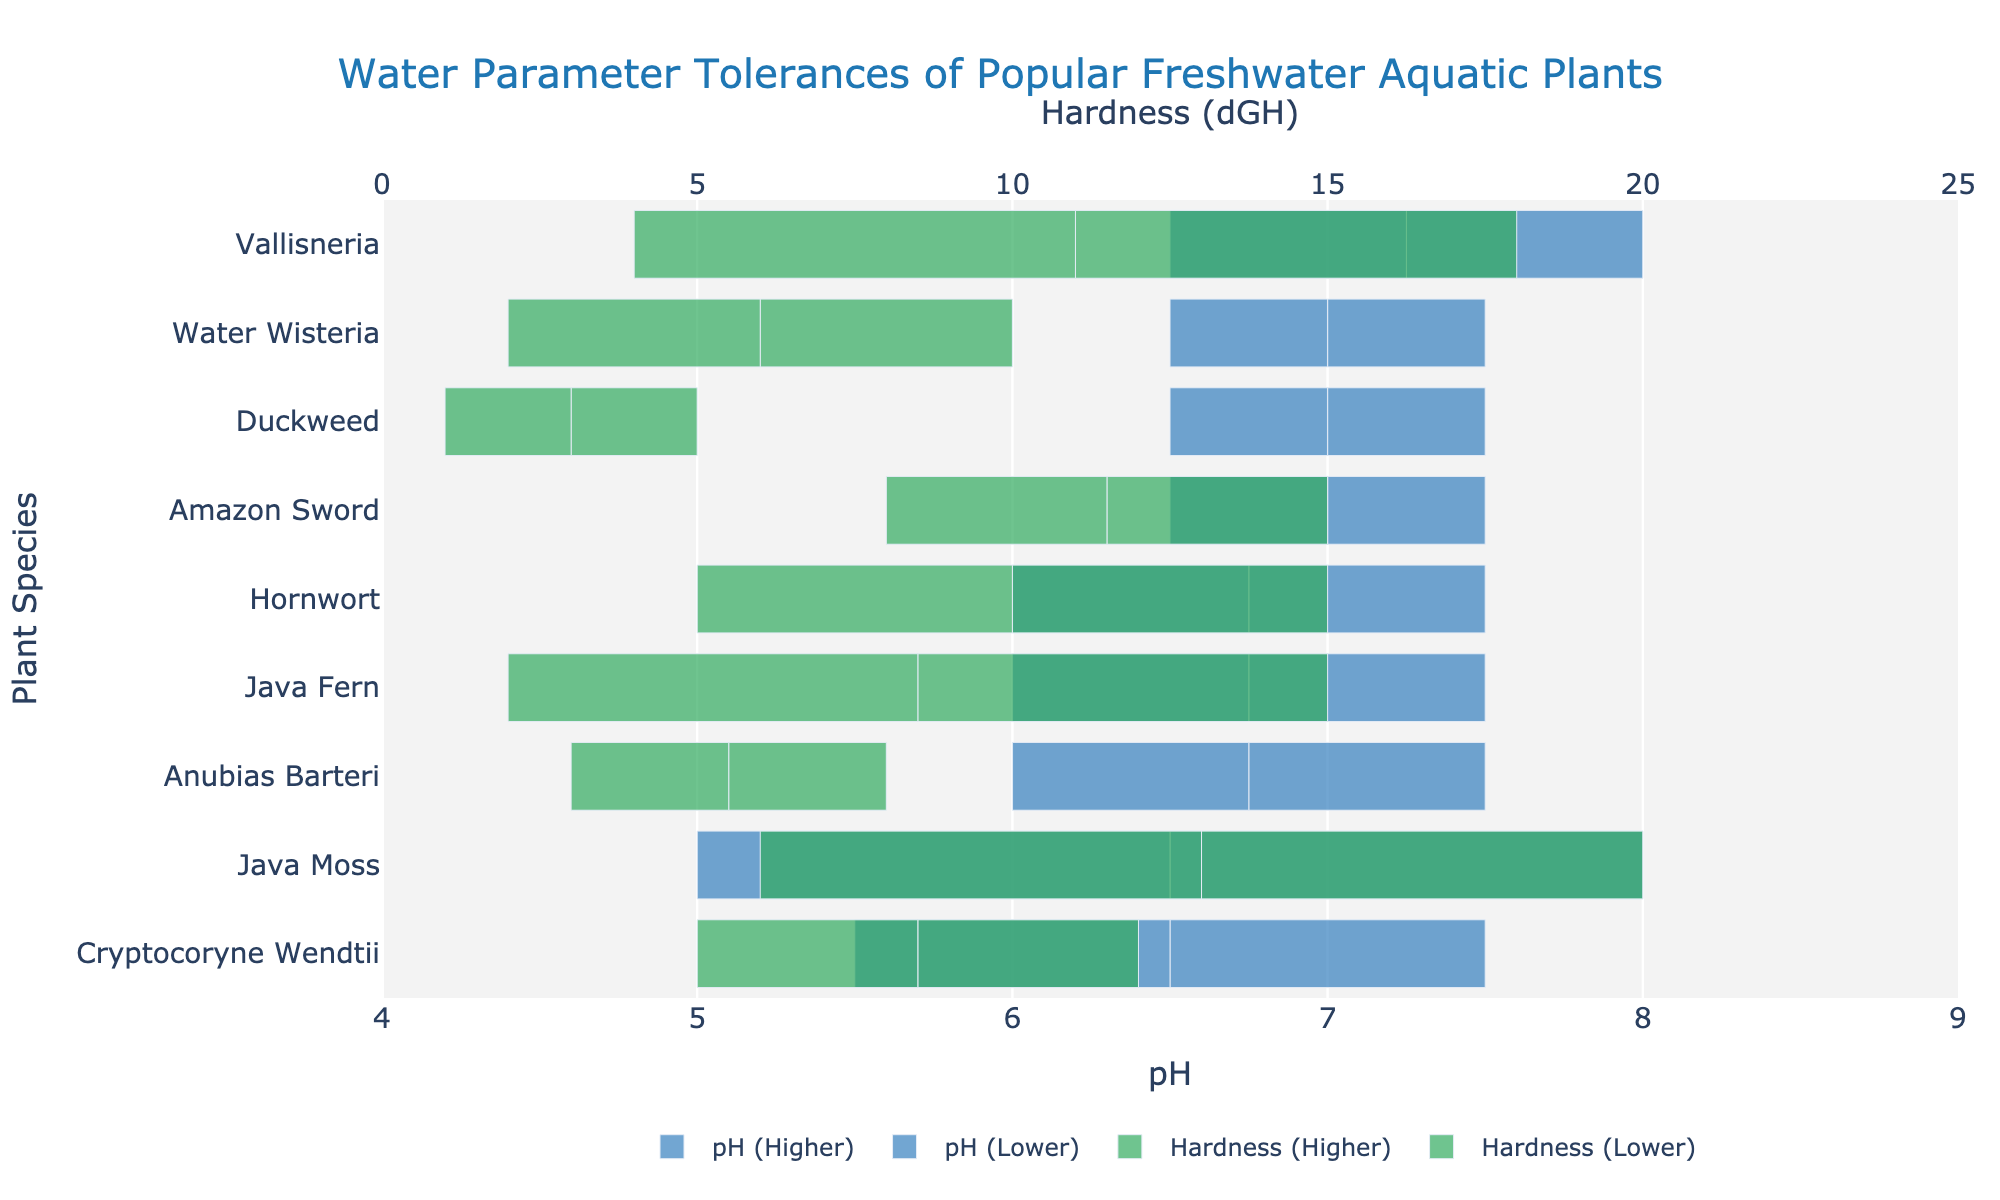Which plant has the widest optimal pH range? To determine this, check the length of the pH range for each plant and identify the widest one. Java Moss's range is from 5.0 to 8.0, covering 3.0 units.
Answer: Java Moss Which two plants overlap the most in their optimal pH ranges? Examine the optimal pH ranges of each plant and see which two ranges overlap the most. Anubias Barteri (6.0-7.5) and Java Fern (6.0-7.5) have identical pH ranges, representing the most overlap.
Answer: Anubias Barteri and Java Fern What is the midpoint of the optimal hardness range for Amazon Sword? Calculate the average of the minimum and maximum hardness values for Amazon Sword. (8 + 15) / 2 = 11.5 dGH.
Answer: 11.5 dGH Is the optimal hardness range for Duckweed narrower than the optimal pH range for Water Wisteria? Compare the lengths of the ranges: Duckweed's hardness range (1-5 dGH) covers 4 units and Water Wisteria's pH range (6.5-7.5) covers 1 unit. Duckweed's hardness range is wider.
Answer: No Which plant can tolerate the highest hardness? Look at the maximum hardness values and identify the highest one. Java Moss tolerates up to 20 dGH.
Answer: Java Moss Which plant's optimal pH midpoint is closest to neutrality (pH 7)? Identify each plant's pH midpoint and find the one closest to 7. For example, Duckweed's range is 6.5-7.5, midpoint = (6.5 + 7.5) / 2 = 7.0. This is closest to neutrality.
Answer: Duckweed How many plants have an optimal pH lower range starting at 6.0? Count the number of plants with a minimum pH of 6.0. Anubias Barteri, Java Fern, and Hornwort all have ranges starting at 6.0.
Answer: 3 What is the average of the minimum hardness values across all plants? To find this, sum the minimum hardness values and divide by the total number of plants (3 + 2 + 8 + 5 + 5 + 6 + 1 + 4 + 2). There are 9 plants; (3+2+8+5+5+6+1+4+2)/9 = 4 dGH.
Answer: 4 dGH Which plants have a pH range that does not vary more than 1 unit? Check each plant's pH range and identify those where the difference between the maximum and minimum is 1 or less. Duckweed (6.5-7.5) and Water Wisteria (6.5-7.5) fit this criterion.
Answer: Duckweed and Water Wisteria Does Hornwort have a wider or narrower hardness range compared to Cryptocoryne Wendtii? Compare the hardness range lengths: Hornwort (5-15 dGH, range = 10) vs. Cryptocoryne Wendtii (5-12 dGH, range = 7). Hornwort's range is wider.
Answer: Wider 